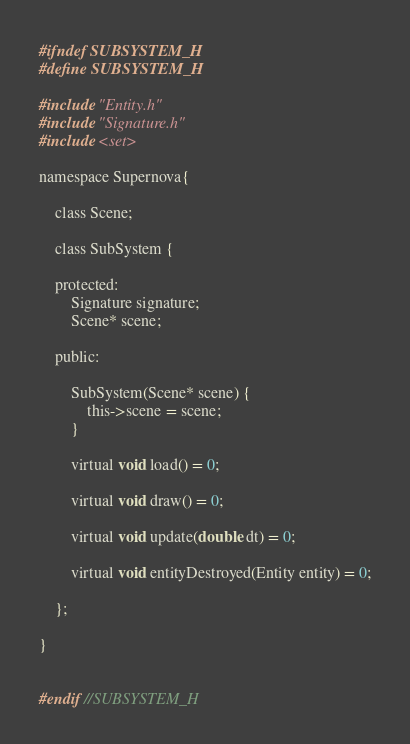Convert code to text. <code><loc_0><loc_0><loc_500><loc_500><_C_>#ifndef SUBSYSTEM_H
#define SUBSYSTEM_H

#include "Entity.h"
#include "Signature.h"
#include <set>

namespace Supernova{

	class Scene;

	class SubSystem {

	protected:
		Signature signature;
		Scene* scene;
	
	public:

		SubSystem(Scene* scene) {
			this->scene = scene;
		}

		virtual void load() = 0;

		virtual void draw() = 0;
	
		virtual void update(double dt) = 0;

		virtual void entityDestroyed(Entity entity) = 0;
	
	};

}


#endif //SUBSYSTEM_H</code> 